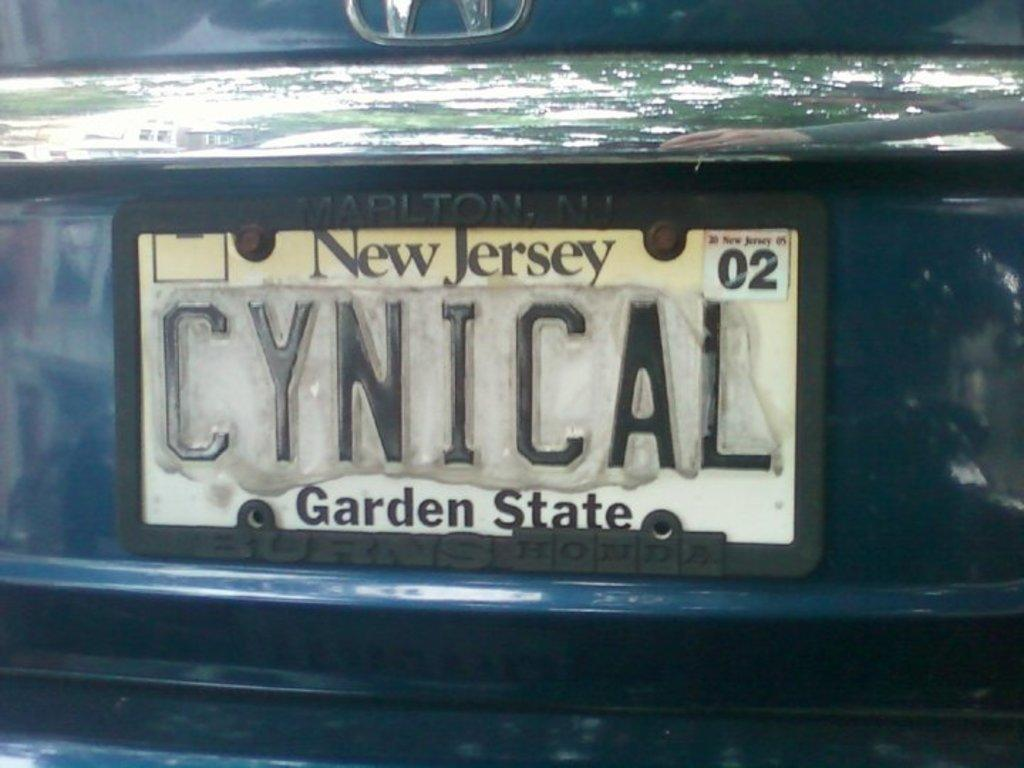<image>
Provide a brief description of the given image. a car license plate from New Jersey the Garden State 